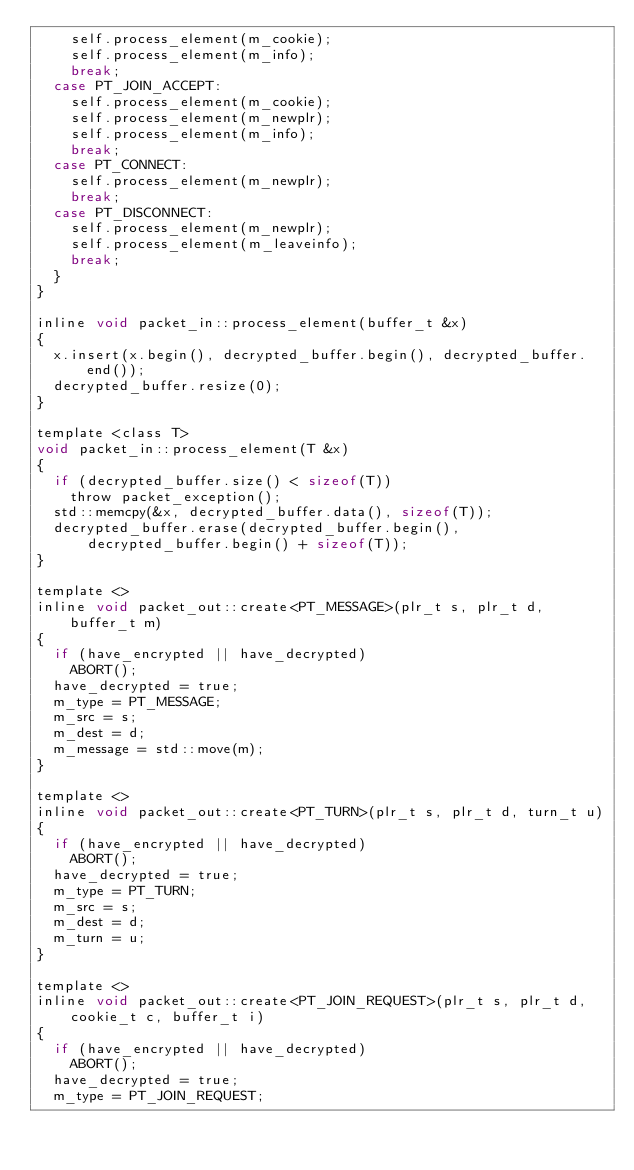<code> <loc_0><loc_0><loc_500><loc_500><_C_>		self.process_element(m_cookie);
		self.process_element(m_info);
		break;
	case PT_JOIN_ACCEPT:
		self.process_element(m_cookie);
		self.process_element(m_newplr);
		self.process_element(m_info);
		break;
	case PT_CONNECT:
		self.process_element(m_newplr);
		break;
	case PT_DISCONNECT:
		self.process_element(m_newplr);
		self.process_element(m_leaveinfo);
		break;
	}
}

inline void packet_in::process_element(buffer_t &x)
{
	x.insert(x.begin(), decrypted_buffer.begin(), decrypted_buffer.end());
	decrypted_buffer.resize(0);
}

template <class T>
void packet_in::process_element(T &x)
{
	if (decrypted_buffer.size() < sizeof(T))
		throw packet_exception();
	std::memcpy(&x, decrypted_buffer.data(), sizeof(T));
	decrypted_buffer.erase(decrypted_buffer.begin(),
	    decrypted_buffer.begin() + sizeof(T));
}

template <>
inline void packet_out::create<PT_MESSAGE>(plr_t s, plr_t d, buffer_t m)
{
	if (have_encrypted || have_decrypted)
		ABORT();
	have_decrypted = true;
	m_type = PT_MESSAGE;
	m_src = s;
	m_dest = d;
	m_message = std::move(m);
}

template <>
inline void packet_out::create<PT_TURN>(plr_t s, plr_t d, turn_t u)
{
	if (have_encrypted || have_decrypted)
		ABORT();
	have_decrypted = true;
	m_type = PT_TURN;
	m_src = s;
	m_dest = d;
	m_turn = u;
}

template <>
inline void packet_out::create<PT_JOIN_REQUEST>(plr_t s, plr_t d,
    cookie_t c, buffer_t i)
{
	if (have_encrypted || have_decrypted)
		ABORT();
	have_decrypted = true;
	m_type = PT_JOIN_REQUEST;</code> 